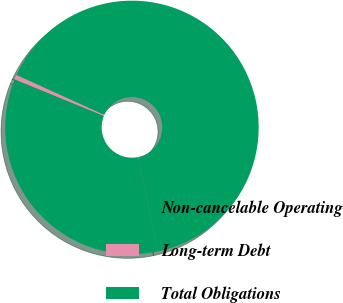Convert chart. <chart><loc_0><loc_0><loc_500><loc_500><pie_chart><fcel>Non-cancelable Operating<fcel>Long-term Debt<fcel>Total Obligations<nl><fcel>34.48%<fcel>0.59%<fcel>64.94%<nl></chart> 